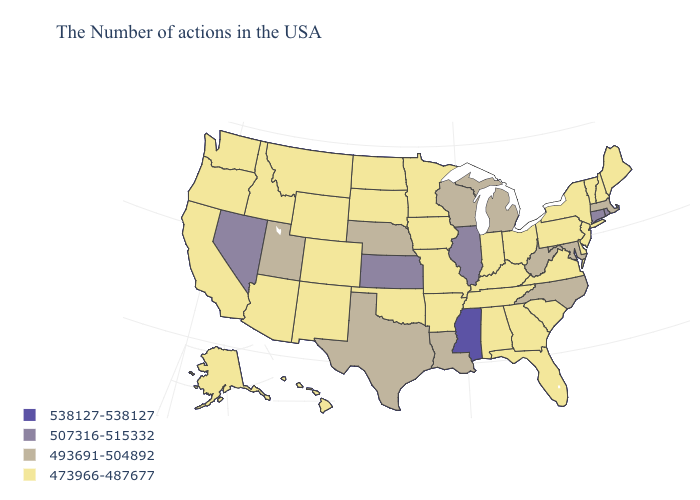Name the states that have a value in the range 507316-515332?
Answer briefly. Rhode Island, Connecticut, Illinois, Kansas, Nevada. What is the value of Montana?
Be succinct. 473966-487677. Does California have a higher value than Indiana?
Quick response, please. No. Does the map have missing data?
Concise answer only. No. What is the value of North Carolina?
Concise answer only. 493691-504892. Name the states that have a value in the range 473966-487677?
Be succinct. Maine, New Hampshire, Vermont, New York, New Jersey, Delaware, Pennsylvania, Virginia, South Carolina, Ohio, Florida, Georgia, Kentucky, Indiana, Alabama, Tennessee, Missouri, Arkansas, Minnesota, Iowa, Oklahoma, South Dakota, North Dakota, Wyoming, Colorado, New Mexico, Montana, Arizona, Idaho, California, Washington, Oregon, Alaska, Hawaii. Does Ohio have a lower value than Mississippi?
Concise answer only. Yes. What is the value of Texas?
Concise answer only. 493691-504892. Name the states that have a value in the range 493691-504892?
Write a very short answer. Massachusetts, Maryland, North Carolina, West Virginia, Michigan, Wisconsin, Louisiana, Nebraska, Texas, Utah. What is the value of Arizona?
Concise answer only. 473966-487677. Name the states that have a value in the range 473966-487677?
Quick response, please. Maine, New Hampshire, Vermont, New York, New Jersey, Delaware, Pennsylvania, Virginia, South Carolina, Ohio, Florida, Georgia, Kentucky, Indiana, Alabama, Tennessee, Missouri, Arkansas, Minnesota, Iowa, Oklahoma, South Dakota, North Dakota, Wyoming, Colorado, New Mexico, Montana, Arizona, Idaho, California, Washington, Oregon, Alaska, Hawaii. Which states hav the highest value in the South?
Write a very short answer. Mississippi. Does California have the lowest value in the West?
Quick response, please. Yes. Name the states that have a value in the range 493691-504892?
Answer briefly. Massachusetts, Maryland, North Carolina, West Virginia, Michigan, Wisconsin, Louisiana, Nebraska, Texas, Utah. Which states have the highest value in the USA?
Write a very short answer. Mississippi. 